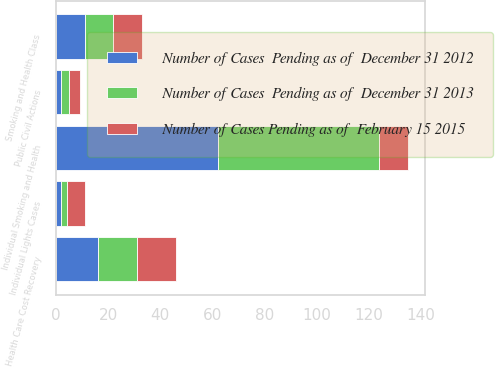<chart> <loc_0><loc_0><loc_500><loc_500><stacked_bar_chart><ecel><fcel>Individual Smoking and Health<fcel>Smoking and Health Class<fcel>Health Care Cost Recovery<fcel>Individual Lights Cases<fcel>Public Civil Actions<nl><fcel>Number of Cases  Pending as of  December 31 2012<fcel>62<fcel>11<fcel>16<fcel>2<fcel>2<nl><fcel>Number of Cases  Pending as of  December 31 2013<fcel>62<fcel>11<fcel>15<fcel>2<fcel>3<nl><fcel>Number of Cases Pending as of  February 15 2015<fcel>11<fcel>11<fcel>15<fcel>7<fcel>4<nl></chart> 